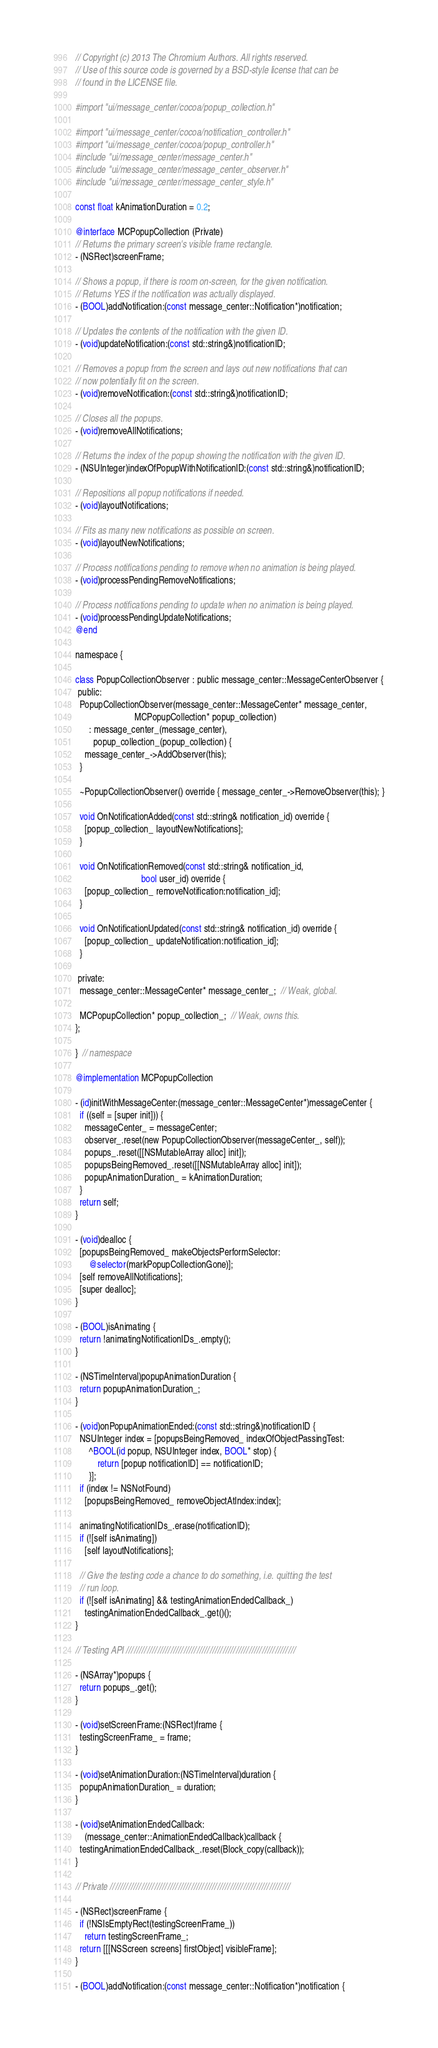Convert code to text. <code><loc_0><loc_0><loc_500><loc_500><_ObjectiveC_>// Copyright (c) 2013 The Chromium Authors. All rights reserved.
// Use of this source code is governed by a BSD-style license that can be
// found in the LICENSE file.

#import "ui/message_center/cocoa/popup_collection.h"

#import "ui/message_center/cocoa/notification_controller.h"
#import "ui/message_center/cocoa/popup_controller.h"
#include "ui/message_center/message_center.h"
#include "ui/message_center/message_center_observer.h"
#include "ui/message_center/message_center_style.h"

const float kAnimationDuration = 0.2;

@interface MCPopupCollection (Private)
// Returns the primary screen's visible frame rectangle.
- (NSRect)screenFrame;

// Shows a popup, if there is room on-screen, for the given notification.
// Returns YES if the notification was actually displayed.
- (BOOL)addNotification:(const message_center::Notification*)notification;

// Updates the contents of the notification with the given ID.
- (void)updateNotification:(const std::string&)notificationID;

// Removes a popup from the screen and lays out new notifications that can
// now potentially fit on the screen.
- (void)removeNotification:(const std::string&)notificationID;

// Closes all the popups.
- (void)removeAllNotifications;

// Returns the index of the popup showing the notification with the given ID.
- (NSUInteger)indexOfPopupWithNotificationID:(const std::string&)notificationID;

// Repositions all popup notifications if needed.
- (void)layoutNotifications;

// Fits as many new notifications as possible on screen.
- (void)layoutNewNotifications;

// Process notifications pending to remove when no animation is being played.
- (void)processPendingRemoveNotifications;

// Process notifications pending to update when no animation is being played.
- (void)processPendingUpdateNotifications;
@end

namespace {

class PopupCollectionObserver : public message_center::MessageCenterObserver {
 public:
  PopupCollectionObserver(message_center::MessageCenter* message_center,
                          MCPopupCollection* popup_collection)
      : message_center_(message_center),
        popup_collection_(popup_collection) {
    message_center_->AddObserver(this);
  }

  ~PopupCollectionObserver() override { message_center_->RemoveObserver(this); }

  void OnNotificationAdded(const std::string& notification_id) override {
    [popup_collection_ layoutNewNotifications];
  }

  void OnNotificationRemoved(const std::string& notification_id,
                             bool user_id) override {
    [popup_collection_ removeNotification:notification_id];
  }

  void OnNotificationUpdated(const std::string& notification_id) override {
    [popup_collection_ updateNotification:notification_id];
  }

 private:
  message_center::MessageCenter* message_center_;  // Weak, global.

  MCPopupCollection* popup_collection_;  // Weak, owns this.
};

}  // namespace

@implementation MCPopupCollection

- (id)initWithMessageCenter:(message_center::MessageCenter*)messageCenter {
  if ((self = [super init])) {
    messageCenter_ = messageCenter;
    observer_.reset(new PopupCollectionObserver(messageCenter_, self));
    popups_.reset([[NSMutableArray alloc] init]);
    popupsBeingRemoved_.reset([[NSMutableArray alloc] init]);
    popupAnimationDuration_ = kAnimationDuration;
  }
  return self;
}

- (void)dealloc {
  [popupsBeingRemoved_ makeObjectsPerformSelector:
      @selector(markPopupCollectionGone)];
  [self removeAllNotifications];
  [super dealloc];
}

- (BOOL)isAnimating {
  return !animatingNotificationIDs_.empty();
}

- (NSTimeInterval)popupAnimationDuration {
  return popupAnimationDuration_;
}

- (void)onPopupAnimationEnded:(const std::string&)notificationID {
  NSUInteger index = [popupsBeingRemoved_ indexOfObjectPassingTest:
      ^BOOL(id popup, NSUInteger index, BOOL* stop) {
          return [popup notificationID] == notificationID;
      }];
  if (index != NSNotFound)
    [popupsBeingRemoved_ removeObjectAtIndex:index];

  animatingNotificationIDs_.erase(notificationID);
  if (![self isAnimating])
    [self layoutNotifications];

  // Give the testing code a chance to do something, i.e. quitting the test
  // run loop.
  if (![self isAnimating] && testingAnimationEndedCallback_)
    testingAnimationEndedCallback_.get()();
}

// Testing API /////////////////////////////////////////////////////////////////

- (NSArray*)popups {
  return popups_.get();
}

- (void)setScreenFrame:(NSRect)frame {
  testingScreenFrame_ = frame;
}

- (void)setAnimationDuration:(NSTimeInterval)duration {
  popupAnimationDuration_ = duration;
}

- (void)setAnimationEndedCallback:
    (message_center::AnimationEndedCallback)callback {
  testingAnimationEndedCallback_.reset(Block_copy(callback));
}

// Private /////////////////////////////////////////////////////////////////////

- (NSRect)screenFrame {
  if (!NSIsEmptyRect(testingScreenFrame_))
    return testingScreenFrame_;
  return [[[NSScreen screens] firstObject] visibleFrame];
}

- (BOOL)addNotification:(const message_center::Notification*)notification {</code> 